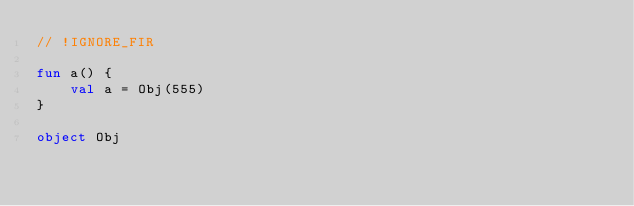<code> <loc_0><loc_0><loc_500><loc_500><_Kotlin_>// !IGNORE_FIR

fun a() {
    val a = Obj(555)
}

object Obj
</code> 